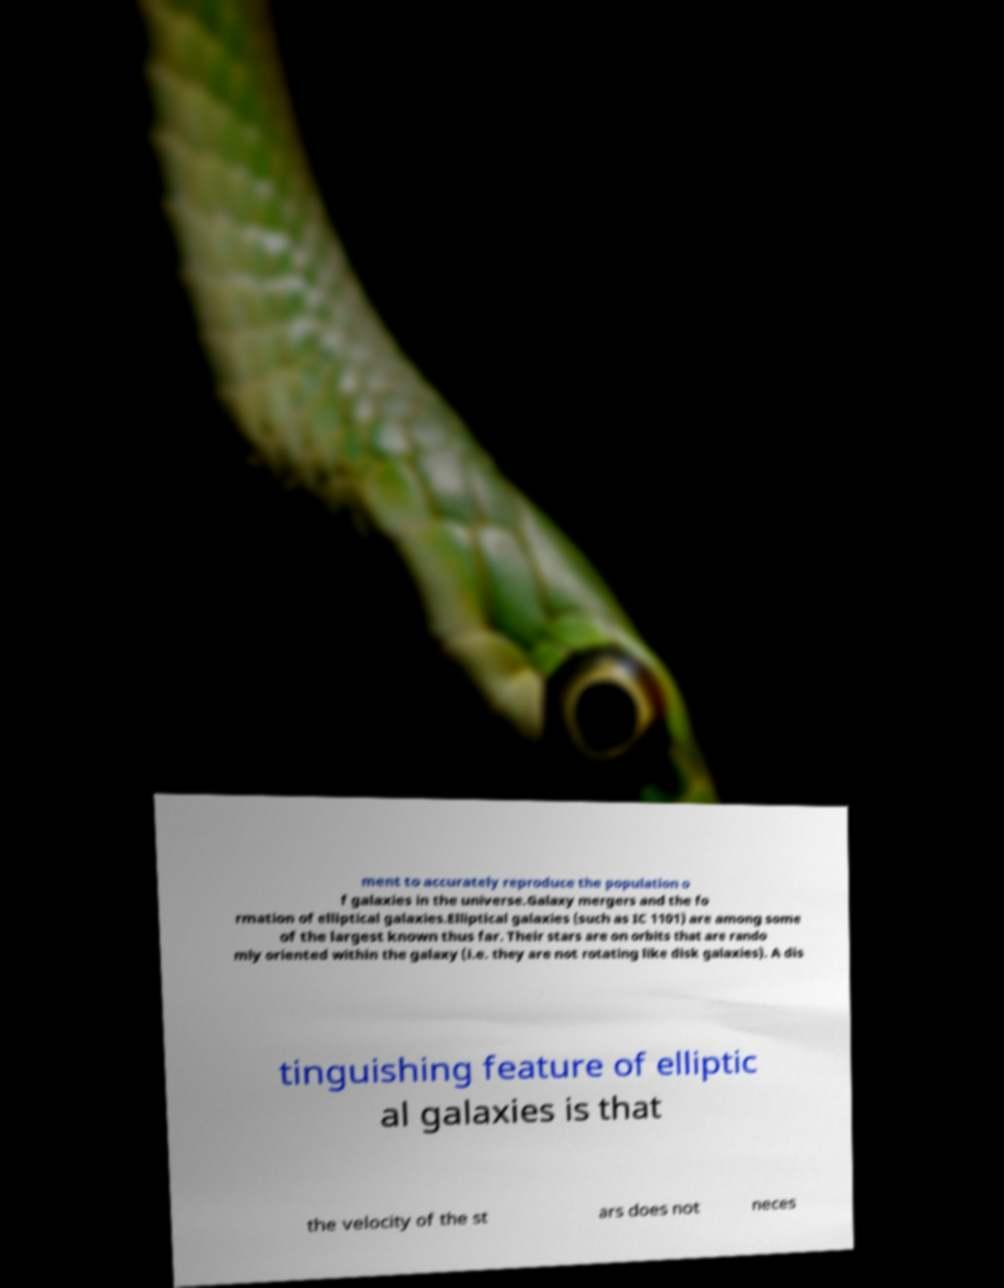For documentation purposes, I need the text within this image transcribed. Could you provide that? ment to accurately reproduce the population o f galaxies in the universe.Galaxy mergers and the fo rmation of elliptical galaxies.Elliptical galaxies (such as IC 1101) are among some of the largest known thus far. Their stars are on orbits that are rando mly oriented within the galaxy (i.e. they are not rotating like disk galaxies). A dis tinguishing feature of elliptic al galaxies is that the velocity of the st ars does not neces 